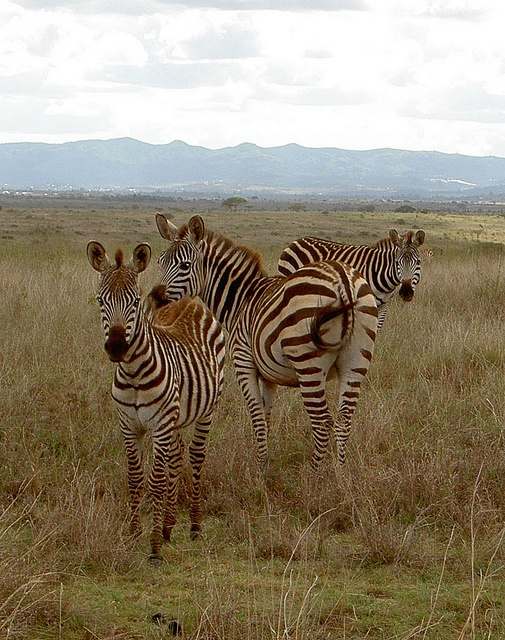Describe the objects in this image and their specific colors. I can see zebra in white, black, maroon, and gray tones, zebra in white, black, olive, maroon, and gray tones, and zebra in white, black, maroon, and gray tones in this image. 